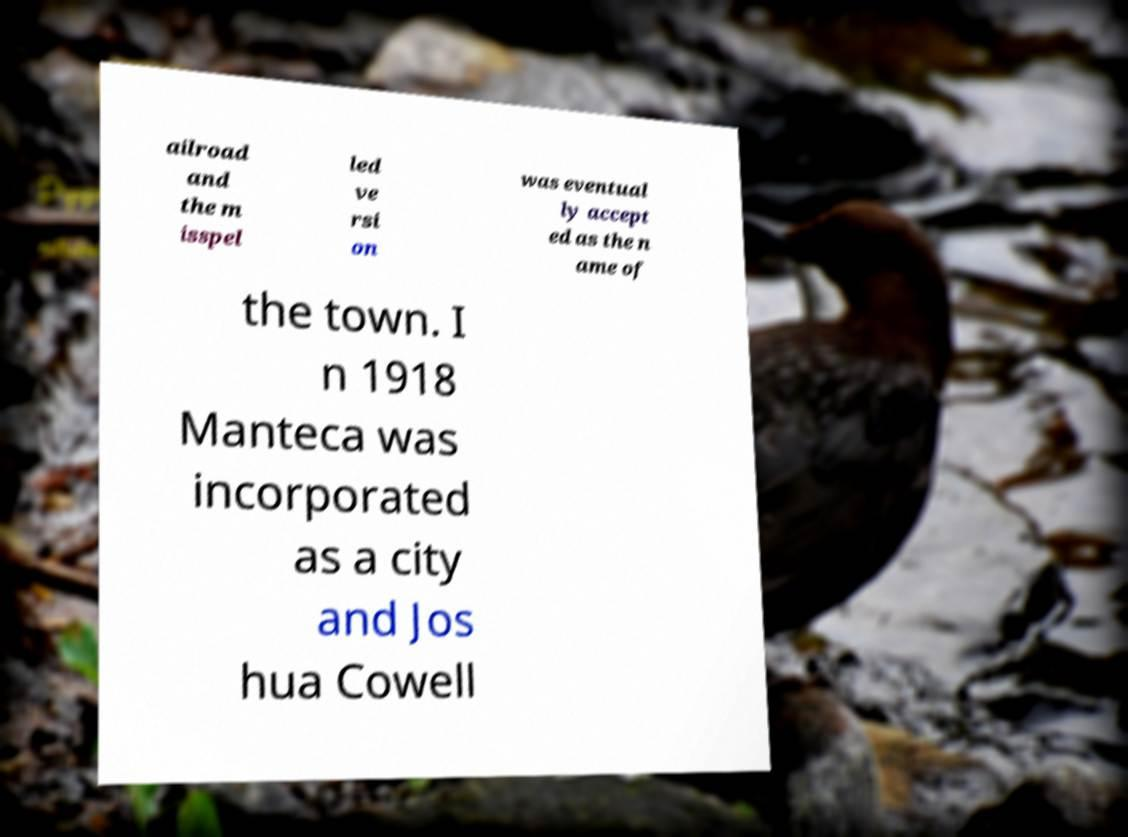Could you extract and type out the text from this image? ailroad and the m isspel led ve rsi on was eventual ly accept ed as the n ame of the town. I n 1918 Manteca was incorporated as a city and Jos hua Cowell 